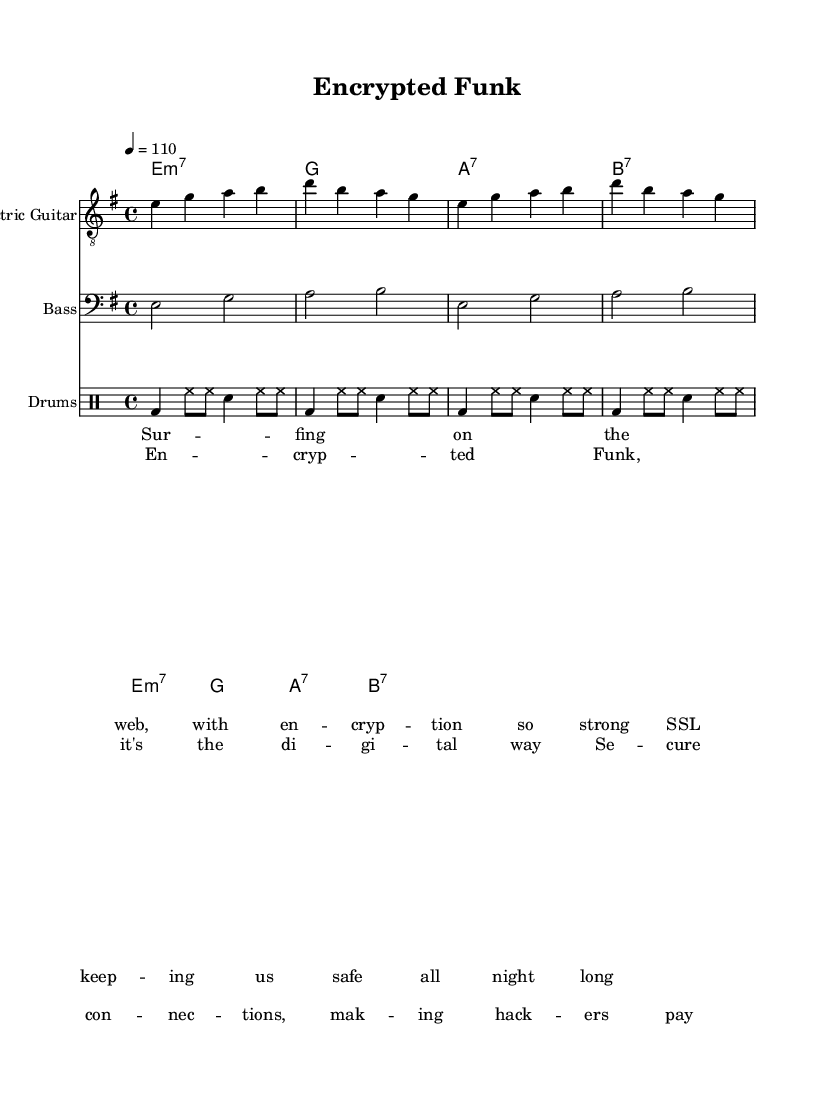What is the key signature of this music? The key signature is E minor, which has one sharp (F#). This can be determined from the key indicated in the global settings.
Answer: E minor What is the time signature of this music? The time signature is 4/4, as specified in the global settings. This means there are four beats in each measure, and the quarter note gets one beat.
Answer: 4/4 What is the tempo marking of this music? The tempo marking is 110 beats per minute, as indicated by the "4 = 110" notation in the global settings.
Answer: 110 How many measures are in the provided sections? There are a total of 16 measures when counting the measures in the electric guitar, bass, and drums parts combined, which consist of 4 measures each for 4 different sections (verse and chorus).
Answer: 16 What instrument plays the lowest pitch in this score? The bass guitar, written in the bass clef, plays the lowest pitches in this score, starting on E and extending higher but remaining lower than the electric guitar.
Answer: Bass guitar Which part of the music has lyrics associated with it? The lyrics are associated with both the verse and the chorus sections, as indicated by the separate lyrics commands in the score, which show that the lyrics are set to specific musical phrases.
Answer: Verse and chorus What is the primary theme expressed in the lyrics? The primary theme expressed in the lyrics is the celebration of encryption and digital security, contrasting with the ease of online communication; this can be inferred from repeated references to encryption and secure connections.
Answer: Digital security 